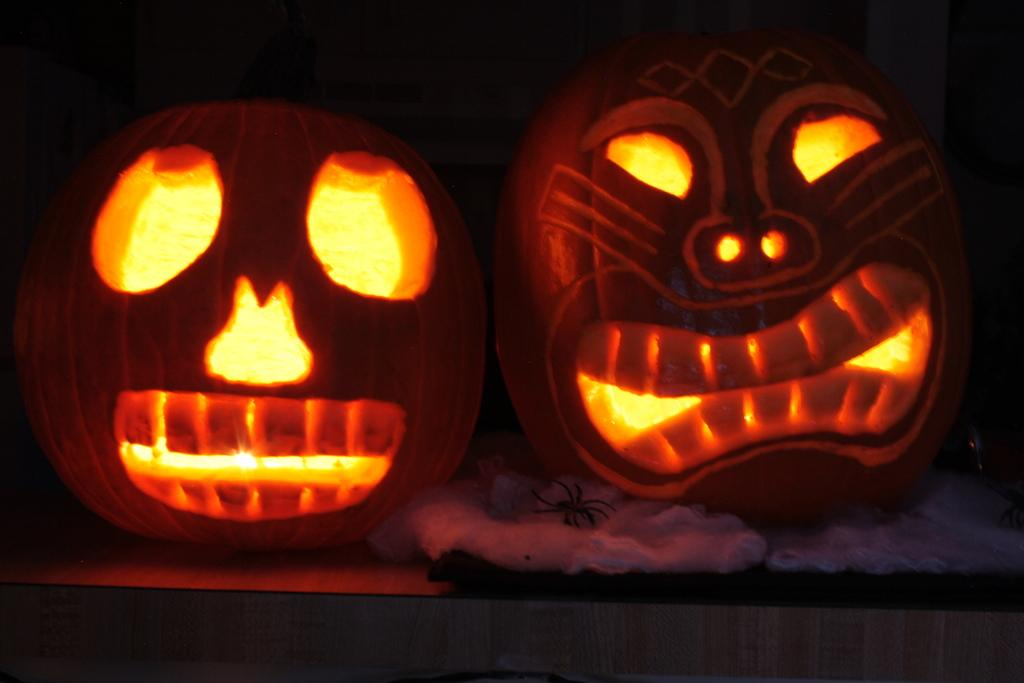What type of decorations can be seen in the image? There are carved pumpkins in the image. What else is present on the desk in the image? Lights are present on a desk in the image. Can you describe an object located below the pumpkin? There is an object in the image that looks like a cotton pad, located below the pumpkin. What type of plough is being used to join the pumpkins together in the image? There is no plough or any indication of joining the pumpkins together in the image. 